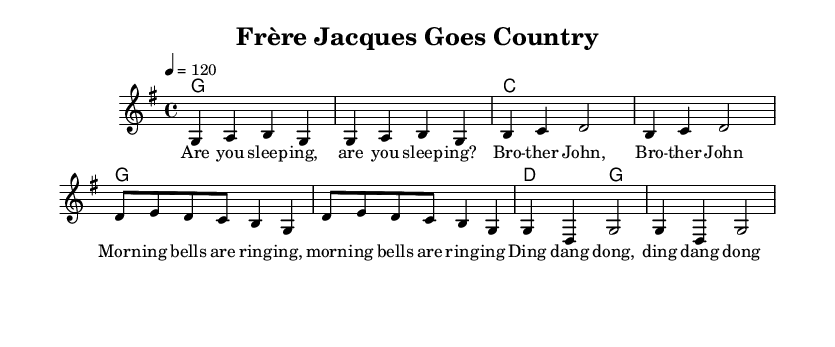What is the key signature of this music? The key signature is G major, which has one sharp (F#). This can be identified in the global section of the sheet music where the key is specified.
Answer: G major What is the time signature of this music? The time signature is 4/4, as indicated in the global section of the sheet music. This means there are four beats in each measure, and each beat is a quarter note.
Answer: 4/4 What is the tempo marking of this music? The tempo marking is given as 4 = 120, indicating that the quarter note should be played at a rate of 120 beats per minute. This can be found directly in the global section of the music notation.
Answer: 120 How many measures are there in the melody? There are 8 measures in the melody, as counted from the melody line where each segment separated by a vertical line (bar line) represents one measure.
Answer: 8 What is the primary genre of this piece? The primary genre of this piece is Country Rock, as indicated by the title and arranged style of the music. This genre typically blends country music with rock elements, which is reflected in the upbeat feel of the notation.
Answer: Country Rock What melodic structure is used in the song? The melodic structure employs a simple repetitive pattern, evident in the way phrases recur throughout the melody. This repetition is common in children’s folk songs, making them easy to sing along to.
Answer: Repetitive pattern What children's folk song is adapted in this composition? The children's folk song adapted in this composition is "Frère Jacques," a well-known children's song from French culture. The lyrics provided in the verse correspond to this traditional melody.
Answer: Frère Jacques 